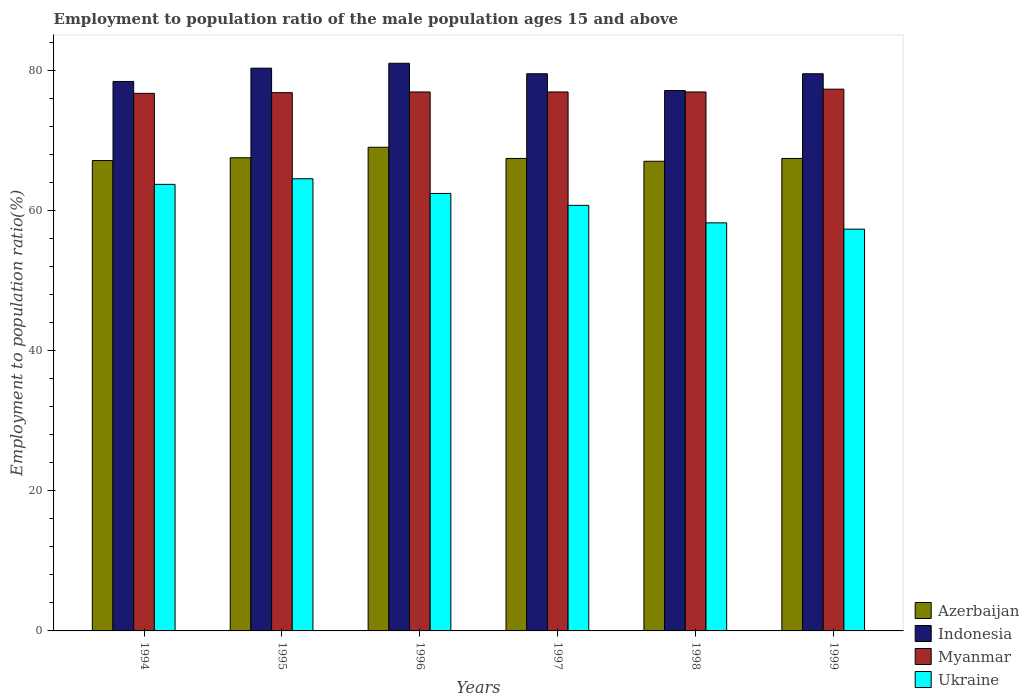How many different coloured bars are there?
Offer a terse response. 4. Are the number of bars per tick equal to the number of legend labels?
Provide a succinct answer. Yes. Are the number of bars on each tick of the X-axis equal?
Give a very brief answer. Yes. What is the label of the 2nd group of bars from the left?
Provide a short and direct response. 1995. In how many cases, is the number of bars for a given year not equal to the number of legend labels?
Give a very brief answer. 0. What is the employment to population ratio in Myanmar in 1994?
Provide a succinct answer. 76.8. Across all years, what is the maximum employment to population ratio in Ukraine?
Your answer should be compact. 64.6. Across all years, what is the minimum employment to population ratio in Ukraine?
Make the answer very short. 57.4. In which year was the employment to population ratio in Azerbaijan maximum?
Your answer should be compact. 1996. What is the total employment to population ratio in Indonesia in the graph?
Your answer should be very brief. 476.4. What is the difference between the employment to population ratio in Indonesia in 1994 and that in 1995?
Your answer should be very brief. -1.9. What is the average employment to population ratio in Azerbaijan per year?
Provide a short and direct response. 67.67. In the year 1994, what is the difference between the employment to population ratio in Myanmar and employment to population ratio in Ukraine?
Make the answer very short. 13. In how many years, is the employment to population ratio in Indonesia greater than 56 %?
Keep it short and to the point. 6. What is the ratio of the employment to population ratio in Myanmar in 1998 to that in 1999?
Give a very brief answer. 0.99. What is the difference between the highest and the second highest employment to population ratio in Ukraine?
Your answer should be compact. 0.8. What is the difference between the highest and the lowest employment to population ratio in Azerbaijan?
Provide a succinct answer. 2. Is the sum of the employment to population ratio in Indonesia in 1994 and 1999 greater than the maximum employment to population ratio in Ukraine across all years?
Your response must be concise. Yes. Is it the case that in every year, the sum of the employment to population ratio in Indonesia and employment to population ratio in Ukraine is greater than the sum of employment to population ratio in Azerbaijan and employment to population ratio in Myanmar?
Provide a succinct answer. Yes. What does the 3rd bar from the left in 1996 represents?
Offer a very short reply. Myanmar. What does the 1st bar from the right in 1996 represents?
Your answer should be compact. Ukraine. How many bars are there?
Ensure brevity in your answer.  24. Are all the bars in the graph horizontal?
Your answer should be compact. No. How many years are there in the graph?
Offer a terse response. 6. Does the graph contain grids?
Provide a succinct answer. No. Where does the legend appear in the graph?
Offer a very short reply. Bottom right. How many legend labels are there?
Provide a short and direct response. 4. What is the title of the graph?
Offer a terse response. Employment to population ratio of the male population ages 15 and above. Does "Belgium" appear as one of the legend labels in the graph?
Your response must be concise. No. What is the label or title of the Y-axis?
Your response must be concise. Employment to population ratio(%). What is the Employment to population ratio(%) in Azerbaijan in 1994?
Provide a succinct answer. 67.2. What is the Employment to population ratio(%) of Indonesia in 1994?
Give a very brief answer. 78.5. What is the Employment to population ratio(%) of Myanmar in 1994?
Give a very brief answer. 76.8. What is the Employment to population ratio(%) of Ukraine in 1994?
Make the answer very short. 63.8. What is the Employment to population ratio(%) of Azerbaijan in 1995?
Provide a succinct answer. 67.6. What is the Employment to population ratio(%) of Indonesia in 1995?
Provide a succinct answer. 80.4. What is the Employment to population ratio(%) in Myanmar in 1995?
Your response must be concise. 76.9. What is the Employment to population ratio(%) of Ukraine in 1995?
Your answer should be very brief. 64.6. What is the Employment to population ratio(%) of Azerbaijan in 1996?
Ensure brevity in your answer.  69.1. What is the Employment to population ratio(%) of Indonesia in 1996?
Make the answer very short. 81.1. What is the Employment to population ratio(%) of Ukraine in 1996?
Offer a terse response. 62.5. What is the Employment to population ratio(%) of Azerbaijan in 1997?
Provide a succinct answer. 67.5. What is the Employment to population ratio(%) of Indonesia in 1997?
Provide a succinct answer. 79.6. What is the Employment to population ratio(%) in Ukraine in 1997?
Provide a short and direct response. 60.8. What is the Employment to population ratio(%) of Azerbaijan in 1998?
Provide a short and direct response. 67.1. What is the Employment to population ratio(%) of Indonesia in 1998?
Provide a short and direct response. 77.2. What is the Employment to population ratio(%) in Myanmar in 1998?
Offer a terse response. 77. What is the Employment to population ratio(%) in Ukraine in 1998?
Keep it short and to the point. 58.3. What is the Employment to population ratio(%) in Azerbaijan in 1999?
Provide a short and direct response. 67.5. What is the Employment to population ratio(%) in Indonesia in 1999?
Provide a short and direct response. 79.6. What is the Employment to population ratio(%) of Myanmar in 1999?
Make the answer very short. 77.4. What is the Employment to population ratio(%) in Ukraine in 1999?
Give a very brief answer. 57.4. Across all years, what is the maximum Employment to population ratio(%) in Azerbaijan?
Ensure brevity in your answer.  69.1. Across all years, what is the maximum Employment to population ratio(%) in Indonesia?
Keep it short and to the point. 81.1. Across all years, what is the maximum Employment to population ratio(%) of Myanmar?
Your response must be concise. 77.4. Across all years, what is the maximum Employment to population ratio(%) of Ukraine?
Ensure brevity in your answer.  64.6. Across all years, what is the minimum Employment to population ratio(%) of Azerbaijan?
Offer a terse response. 67.1. Across all years, what is the minimum Employment to population ratio(%) in Indonesia?
Make the answer very short. 77.2. Across all years, what is the minimum Employment to population ratio(%) in Myanmar?
Give a very brief answer. 76.8. Across all years, what is the minimum Employment to population ratio(%) of Ukraine?
Provide a short and direct response. 57.4. What is the total Employment to population ratio(%) in Azerbaijan in the graph?
Offer a very short reply. 406. What is the total Employment to population ratio(%) in Indonesia in the graph?
Your answer should be very brief. 476.4. What is the total Employment to population ratio(%) of Myanmar in the graph?
Provide a short and direct response. 462.1. What is the total Employment to population ratio(%) in Ukraine in the graph?
Your answer should be very brief. 367.4. What is the difference between the Employment to population ratio(%) in Indonesia in 1994 and that in 1995?
Give a very brief answer. -1.9. What is the difference between the Employment to population ratio(%) of Myanmar in 1994 and that in 1995?
Offer a terse response. -0.1. What is the difference between the Employment to population ratio(%) in Ukraine in 1994 and that in 1995?
Keep it short and to the point. -0.8. What is the difference between the Employment to population ratio(%) in Azerbaijan in 1994 and that in 1996?
Your answer should be compact. -1.9. What is the difference between the Employment to population ratio(%) of Indonesia in 1994 and that in 1996?
Provide a short and direct response. -2.6. What is the difference between the Employment to population ratio(%) of Ukraine in 1994 and that in 1996?
Provide a short and direct response. 1.3. What is the difference between the Employment to population ratio(%) of Azerbaijan in 1994 and that in 1997?
Provide a short and direct response. -0.3. What is the difference between the Employment to population ratio(%) in Indonesia in 1994 and that in 1997?
Your response must be concise. -1.1. What is the difference between the Employment to population ratio(%) of Azerbaijan in 1994 and that in 1998?
Provide a succinct answer. 0.1. What is the difference between the Employment to population ratio(%) of Ukraine in 1994 and that in 1998?
Your response must be concise. 5.5. What is the difference between the Employment to population ratio(%) of Myanmar in 1994 and that in 1999?
Your answer should be compact. -0.6. What is the difference between the Employment to population ratio(%) in Indonesia in 1995 and that in 1996?
Your response must be concise. -0.7. What is the difference between the Employment to population ratio(%) in Myanmar in 1995 and that in 1996?
Offer a very short reply. -0.1. What is the difference between the Employment to population ratio(%) in Ukraine in 1995 and that in 1996?
Provide a short and direct response. 2.1. What is the difference between the Employment to population ratio(%) of Azerbaijan in 1995 and that in 1997?
Offer a terse response. 0.1. What is the difference between the Employment to population ratio(%) of Indonesia in 1995 and that in 1998?
Make the answer very short. 3.2. What is the difference between the Employment to population ratio(%) in Myanmar in 1995 and that in 1998?
Your answer should be very brief. -0.1. What is the difference between the Employment to population ratio(%) in Indonesia in 1995 and that in 1999?
Provide a succinct answer. 0.8. What is the difference between the Employment to population ratio(%) in Myanmar in 1995 and that in 1999?
Your answer should be very brief. -0.5. What is the difference between the Employment to population ratio(%) in Indonesia in 1996 and that in 1998?
Your response must be concise. 3.9. What is the difference between the Employment to population ratio(%) in Myanmar in 1996 and that in 1998?
Offer a terse response. 0. What is the difference between the Employment to population ratio(%) of Azerbaijan in 1996 and that in 1999?
Provide a succinct answer. 1.6. What is the difference between the Employment to population ratio(%) in Indonesia in 1996 and that in 1999?
Provide a succinct answer. 1.5. What is the difference between the Employment to population ratio(%) of Myanmar in 1996 and that in 1999?
Make the answer very short. -0.4. What is the difference between the Employment to population ratio(%) in Ukraine in 1996 and that in 1999?
Give a very brief answer. 5.1. What is the difference between the Employment to population ratio(%) in Azerbaijan in 1997 and that in 1998?
Your answer should be very brief. 0.4. What is the difference between the Employment to population ratio(%) of Myanmar in 1997 and that in 1998?
Offer a terse response. 0. What is the difference between the Employment to population ratio(%) of Azerbaijan in 1997 and that in 1999?
Offer a terse response. 0. What is the difference between the Employment to population ratio(%) of Myanmar in 1997 and that in 1999?
Your response must be concise. -0.4. What is the difference between the Employment to population ratio(%) of Azerbaijan in 1994 and the Employment to population ratio(%) of Indonesia in 1995?
Offer a terse response. -13.2. What is the difference between the Employment to population ratio(%) of Azerbaijan in 1994 and the Employment to population ratio(%) of Myanmar in 1995?
Your response must be concise. -9.7. What is the difference between the Employment to population ratio(%) in Azerbaijan in 1994 and the Employment to population ratio(%) in Ukraine in 1995?
Your response must be concise. 2.6. What is the difference between the Employment to population ratio(%) of Indonesia in 1994 and the Employment to population ratio(%) of Ukraine in 1995?
Ensure brevity in your answer.  13.9. What is the difference between the Employment to population ratio(%) in Myanmar in 1994 and the Employment to population ratio(%) in Ukraine in 1995?
Offer a terse response. 12.2. What is the difference between the Employment to population ratio(%) of Indonesia in 1994 and the Employment to population ratio(%) of Myanmar in 1996?
Provide a succinct answer. 1.5. What is the difference between the Employment to population ratio(%) of Indonesia in 1994 and the Employment to population ratio(%) of Ukraine in 1996?
Provide a short and direct response. 16. What is the difference between the Employment to population ratio(%) of Azerbaijan in 1994 and the Employment to population ratio(%) of Indonesia in 1997?
Your answer should be very brief. -12.4. What is the difference between the Employment to population ratio(%) in Myanmar in 1994 and the Employment to population ratio(%) in Ukraine in 1997?
Keep it short and to the point. 16. What is the difference between the Employment to population ratio(%) of Azerbaijan in 1994 and the Employment to population ratio(%) of Indonesia in 1998?
Offer a very short reply. -10. What is the difference between the Employment to population ratio(%) of Indonesia in 1994 and the Employment to population ratio(%) of Myanmar in 1998?
Keep it short and to the point. 1.5. What is the difference between the Employment to population ratio(%) of Indonesia in 1994 and the Employment to population ratio(%) of Ukraine in 1998?
Your response must be concise. 20.2. What is the difference between the Employment to population ratio(%) in Azerbaijan in 1994 and the Employment to population ratio(%) in Ukraine in 1999?
Make the answer very short. 9.8. What is the difference between the Employment to population ratio(%) of Indonesia in 1994 and the Employment to population ratio(%) of Myanmar in 1999?
Provide a short and direct response. 1.1. What is the difference between the Employment to population ratio(%) in Indonesia in 1994 and the Employment to population ratio(%) in Ukraine in 1999?
Provide a short and direct response. 21.1. What is the difference between the Employment to population ratio(%) in Myanmar in 1994 and the Employment to population ratio(%) in Ukraine in 1999?
Your response must be concise. 19.4. What is the difference between the Employment to population ratio(%) in Azerbaijan in 1995 and the Employment to population ratio(%) in Indonesia in 1996?
Your answer should be very brief. -13.5. What is the difference between the Employment to population ratio(%) in Azerbaijan in 1995 and the Employment to population ratio(%) in Myanmar in 1996?
Provide a short and direct response. -9.4. What is the difference between the Employment to population ratio(%) of Indonesia in 1995 and the Employment to population ratio(%) of Myanmar in 1996?
Provide a succinct answer. 3.4. What is the difference between the Employment to population ratio(%) of Indonesia in 1995 and the Employment to population ratio(%) of Ukraine in 1996?
Offer a terse response. 17.9. What is the difference between the Employment to population ratio(%) of Azerbaijan in 1995 and the Employment to population ratio(%) of Indonesia in 1997?
Make the answer very short. -12. What is the difference between the Employment to population ratio(%) in Azerbaijan in 1995 and the Employment to population ratio(%) in Myanmar in 1997?
Give a very brief answer. -9.4. What is the difference between the Employment to population ratio(%) of Azerbaijan in 1995 and the Employment to population ratio(%) of Ukraine in 1997?
Provide a succinct answer. 6.8. What is the difference between the Employment to population ratio(%) in Indonesia in 1995 and the Employment to population ratio(%) in Myanmar in 1997?
Provide a short and direct response. 3.4. What is the difference between the Employment to population ratio(%) of Indonesia in 1995 and the Employment to population ratio(%) of Ukraine in 1997?
Your response must be concise. 19.6. What is the difference between the Employment to population ratio(%) in Azerbaijan in 1995 and the Employment to population ratio(%) in Indonesia in 1998?
Provide a short and direct response. -9.6. What is the difference between the Employment to population ratio(%) in Azerbaijan in 1995 and the Employment to population ratio(%) in Myanmar in 1998?
Offer a very short reply. -9.4. What is the difference between the Employment to population ratio(%) of Azerbaijan in 1995 and the Employment to population ratio(%) of Ukraine in 1998?
Your answer should be very brief. 9.3. What is the difference between the Employment to population ratio(%) in Indonesia in 1995 and the Employment to population ratio(%) in Myanmar in 1998?
Give a very brief answer. 3.4. What is the difference between the Employment to population ratio(%) in Indonesia in 1995 and the Employment to population ratio(%) in Ukraine in 1998?
Your answer should be very brief. 22.1. What is the difference between the Employment to population ratio(%) of Myanmar in 1995 and the Employment to population ratio(%) of Ukraine in 1998?
Provide a succinct answer. 18.6. What is the difference between the Employment to population ratio(%) of Indonesia in 1995 and the Employment to population ratio(%) of Myanmar in 1999?
Give a very brief answer. 3. What is the difference between the Employment to population ratio(%) of Myanmar in 1995 and the Employment to population ratio(%) of Ukraine in 1999?
Provide a succinct answer. 19.5. What is the difference between the Employment to population ratio(%) in Azerbaijan in 1996 and the Employment to population ratio(%) in Indonesia in 1997?
Keep it short and to the point. -10.5. What is the difference between the Employment to population ratio(%) in Azerbaijan in 1996 and the Employment to population ratio(%) in Ukraine in 1997?
Give a very brief answer. 8.3. What is the difference between the Employment to population ratio(%) in Indonesia in 1996 and the Employment to population ratio(%) in Myanmar in 1997?
Your answer should be very brief. 4.1. What is the difference between the Employment to population ratio(%) in Indonesia in 1996 and the Employment to population ratio(%) in Ukraine in 1997?
Your answer should be compact. 20.3. What is the difference between the Employment to population ratio(%) in Myanmar in 1996 and the Employment to population ratio(%) in Ukraine in 1997?
Provide a succinct answer. 16.2. What is the difference between the Employment to population ratio(%) of Azerbaijan in 1996 and the Employment to population ratio(%) of Indonesia in 1998?
Offer a very short reply. -8.1. What is the difference between the Employment to population ratio(%) of Azerbaijan in 1996 and the Employment to population ratio(%) of Ukraine in 1998?
Provide a short and direct response. 10.8. What is the difference between the Employment to population ratio(%) in Indonesia in 1996 and the Employment to population ratio(%) in Myanmar in 1998?
Your answer should be compact. 4.1. What is the difference between the Employment to population ratio(%) in Indonesia in 1996 and the Employment to population ratio(%) in Ukraine in 1998?
Offer a very short reply. 22.8. What is the difference between the Employment to population ratio(%) of Myanmar in 1996 and the Employment to population ratio(%) of Ukraine in 1998?
Offer a terse response. 18.7. What is the difference between the Employment to population ratio(%) of Azerbaijan in 1996 and the Employment to population ratio(%) of Myanmar in 1999?
Provide a succinct answer. -8.3. What is the difference between the Employment to population ratio(%) of Indonesia in 1996 and the Employment to population ratio(%) of Ukraine in 1999?
Give a very brief answer. 23.7. What is the difference between the Employment to population ratio(%) in Myanmar in 1996 and the Employment to population ratio(%) in Ukraine in 1999?
Your answer should be very brief. 19.6. What is the difference between the Employment to population ratio(%) in Azerbaijan in 1997 and the Employment to population ratio(%) in Myanmar in 1998?
Ensure brevity in your answer.  -9.5. What is the difference between the Employment to population ratio(%) of Azerbaijan in 1997 and the Employment to population ratio(%) of Ukraine in 1998?
Offer a terse response. 9.2. What is the difference between the Employment to population ratio(%) in Indonesia in 1997 and the Employment to population ratio(%) in Myanmar in 1998?
Ensure brevity in your answer.  2.6. What is the difference between the Employment to population ratio(%) of Indonesia in 1997 and the Employment to population ratio(%) of Ukraine in 1998?
Your answer should be very brief. 21.3. What is the difference between the Employment to population ratio(%) of Myanmar in 1997 and the Employment to population ratio(%) of Ukraine in 1998?
Your answer should be very brief. 18.7. What is the difference between the Employment to population ratio(%) in Azerbaijan in 1997 and the Employment to population ratio(%) in Indonesia in 1999?
Ensure brevity in your answer.  -12.1. What is the difference between the Employment to population ratio(%) of Indonesia in 1997 and the Employment to population ratio(%) of Ukraine in 1999?
Keep it short and to the point. 22.2. What is the difference between the Employment to population ratio(%) in Myanmar in 1997 and the Employment to population ratio(%) in Ukraine in 1999?
Make the answer very short. 19.6. What is the difference between the Employment to population ratio(%) of Azerbaijan in 1998 and the Employment to population ratio(%) of Indonesia in 1999?
Your response must be concise. -12.5. What is the difference between the Employment to population ratio(%) in Azerbaijan in 1998 and the Employment to population ratio(%) in Ukraine in 1999?
Your answer should be compact. 9.7. What is the difference between the Employment to population ratio(%) in Indonesia in 1998 and the Employment to population ratio(%) in Myanmar in 1999?
Give a very brief answer. -0.2. What is the difference between the Employment to population ratio(%) of Indonesia in 1998 and the Employment to population ratio(%) of Ukraine in 1999?
Your answer should be very brief. 19.8. What is the difference between the Employment to population ratio(%) of Myanmar in 1998 and the Employment to population ratio(%) of Ukraine in 1999?
Keep it short and to the point. 19.6. What is the average Employment to population ratio(%) in Azerbaijan per year?
Ensure brevity in your answer.  67.67. What is the average Employment to population ratio(%) in Indonesia per year?
Provide a short and direct response. 79.4. What is the average Employment to population ratio(%) of Myanmar per year?
Keep it short and to the point. 77.02. What is the average Employment to population ratio(%) in Ukraine per year?
Your answer should be very brief. 61.23. In the year 1994, what is the difference between the Employment to population ratio(%) of Azerbaijan and Employment to population ratio(%) of Indonesia?
Offer a very short reply. -11.3. In the year 1994, what is the difference between the Employment to population ratio(%) in Azerbaijan and Employment to population ratio(%) in Myanmar?
Your answer should be very brief. -9.6. In the year 1994, what is the difference between the Employment to population ratio(%) of Azerbaijan and Employment to population ratio(%) of Ukraine?
Your response must be concise. 3.4. In the year 1994, what is the difference between the Employment to population ratio(%) of Indonesia and Employment to population ratio(%) of Myanmar?
Your answer should be compact. 1.7. In the year 1994, what is the difference between the Employment to population ratio(%) in Indonesia and Employment to population ratio(%) in Ukraine?
Your response must be concise. 14.7. In the year 1994, what is the difference between the Employment to population ratio(%) in Myanmar and Employment to population ratio(%) in Ukraine?
Give a very brief answer. 13. In the year 1995, what is the difference between the Employment to population ratio(%) of Indonesia and Employment to population ratio(%) of Myanmar?
Your response must be concise. 3.5. In the year 1995, what is the difference between the Employment to population ratio(%) in Indonesia and Employment to population ratio(%) in Ukraine?
Provide a succinct answer. 15.8. In the year 1995, what is the difference between the Employment to population ratio(%) in Myanmar and Employment to population ratio(%) in Ukraine?
Make the answer very short. 12.3. In the year 1996, what is the difference between the Employment to population ratio(%) in Azerbaijan and Employment to population ratio(%) in Ukraine?
Give a very brief answer. 6.6. In the year 1996, what is the difference between the Employment to population ratio(%) in Indonesia and Employment to population ratio(%) in Ukraine?
Your answer should be compact. 18.6. In the year 1996, what is the difference between the Employment to population ratio(%) of Myanmar and Employment to population ratio(%) of Ukraine?
Make the answer very short. 14.5. In the year 1997, what is the difference between the Employment to population ratio(%) in Azerbaijan and Employment to population ratio(%) in Indonesia?
Ensure brevity in your answer.  -12.1. In the year 1997, what is the difference between the Employment to population ratio(%) in Azerbaijan and Employment to population ratio(%) in Ukraine?
Make the answer very short. 6.7. In the year 1997, what is the difference between the Employment to population ratio(%) of Indonesia and Employment to population ratio(%) of Myanmar?
Provide a succinct answer. 2.6. In the year 1997, what is the difference between the Employment to population ratio(%) of Indonesia and Employment to population ratio(%) of Ukraine?
Your response must be concise. 18.8. In the year 1997, what is the difference between the Employment to population ratio(%) of Myanmar and Employment to population ratio(%) of Ukraine?
Ensure brevity in your answer.  16.2. In the year 1998, what is the difference between the Employment to population ratio(%) of Azerbaijan and Employment to population ratio(%) of Ukraine?
Make the answer very short. 8.8. In the year 1998, what is the difference between the Employment to population ratio(%) in Indonesia and Employment to population ratio(%) in Ukraine?
Your answer should be compact. 18.9. In the year 1998, what is the difference between the Employment to population ratio(%) in Myanmar and Employment to population ratio(%) in Ukraine?
Your response must be concise. 18.7. In the year 1999, what is the difference between the Employment to population ratio(%) in Myanmar and Employment to population ratio(%) in Ukraine?
Offer a very short reply. 20. What is the ratio of the Employment to population ratio(%) in Indonesia in 1994 to that in 1995?
Keep it short and to the point. 0.98. What is the ratio of the Employment to population ratio(%) of Myanmar in 1994 to that in 1995?
Provide a succinct answer. 1. What is the ratio of the Employment to population ratio(%) in Ukraine in 1994 to that in 1995?
Ensure brevity in your answer.  0.99. What is the ratio of the Employment to population ratio(%) of Azerbaijan in 1994 to that in 1996?
Make the answer very short. 0.97. What is the ratio of the Employment to population ratio(%) in Indonesia in 1994 to that in 1996?
Your answer should be very brief. 0.97. What is the ratio of the Employment to population ratio(%) in Ukraine in 1994 to that in 1996?
Keep it short and to the point. 1.02. What is the ratio of the Employment to population ratio(%) in Azerbaijan in 1994 to that in 1997?
Your response must be concise. 1. What is the ratio of the Employment to population ratio(%) in Indonesia in 1994 to that in 1997?
Provide a succinct answer. 0.99. What is the ratio of the Employment to population ratio(%) in Ukraine in 1994 to that in 1997?
Offer a very short reply. 1.05. What is the ratio of the Employment to population ratio(%) of Azerbaijan in 1994 to that in 1998?
Your response must be concise. 1. What is the ratio of the Employment to population ratio(%) of Indonesia in 1994 to that in 1998?
Your answer should be very brief. 1.02. What is the ratio of the Employment to population ratio(%) in Myanmar in 1994 to that in 1998?
Make the answer very short. 1. What is the ratio of the Employment to population ratio(%) of Ukraine in 1994 to that in 1998?
Ensure brevity in your answer.  1.09. What is the ratio of the Employment to population ratio(%) of Azerbaijan in 1994 to that in 1999?
Provide a short and direct response. 1. What is the ratio of the Employment to population ratio(%) of Indonesia in 1994 to that in 1999?
Your answer should be very brief. 0.99. What is the ratio of the Employment to population ratio(%) of Ukraine in 1994 to that in 1999?
Ensure brevity in your answer.  1.11. What is the ratio of the Employment to population ratio(%) of Azerbaijan in 1995 to that in 1996?
Your answer should be compact. 0.98. What is the ratio of the Employment to population ratio(%) of Indonesia in 1995 to that in 1996?
Give a very brief answer. 0.99. What is the ratio of the Employment to population ratio(%) of Ukraine in 1995 to that in 1996?
Your response must be concise. 1.03. What is the ratio of the Employment to population ratio(%) in Azerbaijan in 1995 to that in 1997?
Your answer should be compact. 1. What is the ratio of the Employment to population ratio(%) in Indonesia in 1995 to that in 1997?
Keep it short and to the point. 1.01. What is the ratio of the Employment to population ratio(%) of Myanmar in 1995 to that in 1997?
Provide a short and direct response. 1. What is the ratio of the Employment to population ratio(%) in Ukraine in 1995 to that in 1997?
Make the answer very short. 1.06. What is the ratio of the Employment to population ratio(%) in Azerbaijan in 1995 to that in 1998?
Your response must be concise. 1.01. What is the ratio of the Employment to population ratio(%) in Indonesia in 1995 to that in 1998?
Provide a succinct answer. 1.04. What is the ratio of the Employment to population ratio(%) in Ukraine in 1995 to that in 1998?
Keep it short and to the point. 1.11. What is the ratio of the Employment to population ratio(%) of Indonesia in 1995 to that in 1999?
Your response must be concise. 1.01. What is the ratio of the Employment to population ratio(%) of Myanmar in 1995 to that in 1999?
Your response must be concise. 0.99. What is the ratio of the Employment to population ratio(%) in Ukraine in 1995 to that in 1999?
Offer a very short reply. 1.13. What is the ratio of the Employment to population ratio(%) in Azerbaijan in 1996 to that in 1997?
Give a very brief answer. 1.02. What is the ratio of the Employment to population ratio(%) in Indonesia in 1996 to that in 1997?
Offer a terse response. 1.02. What is the ratio of the Employment to population ratio(%) of Ukraine in 1996 to that in 1997?
Offer a terse response. 1.03. What is the ratio of the Employment to population ratio(%) of Azerbaijan in 1996 to that in 1998?
Your response must be concise. 1.03. What is the ratio of the Employment to population ratio(%) in Indonesia in 1996 to that in 1998?
Your response must be concise. 1.05. What is the ratio of the Employment to population ratio(%) of Ukraine in 1996 to that in 1998?
Provide a short and direct response. 1.07. What is the ratio of the Employment to population ratio(%) of Azerbaijan in 1996 to that in 1999?
Provide a short and direct response. 1.02. What is the ratio of the Employment to population ratio(%) of Indonesia in 1996 to that in 1999?
Provide a short and direct response. 1.02. What is the ratio of the Employment to population ratio(%) in Ukraine in 1996 to that in 1999?
Make the answer very short. 1.09. What is the ratio of the Employment to population ratio(%) of Azerbaijan in 1997 to that in 1998?
Give a very brief answer. 1.01. What is the ratio of the Employment to population ratio(%) in Indonesia in 1997 to that in 1998?
Offer a terse response. 1.03. What is the ratio of the Employment to population ratio(%) of Myanmar in 1997 to that in 1998?
Ensure brevity in your answer.  1. What is the ratio of the Employment to population ratio(%) in Ukraine in 1997 to that in 1998?
Keep it short and to the point. 1.04. What is the ratio of the Employment to population ratio(%) of Indonesia in 1997 to that in 1999?
Your response must be concise. 1. What is the ratio of the Employment to population ratio(%) of Ukraine in 1997 to that in 1999?
Keep it short and to the point. 1.06. What is the ratio of the Employment to population ratio(%) in Indonesia in 1998 to that in 1999?
Ensure brevity in your answer.  0.97. What is the ratio of the Employment to population ratio(%) of Ukraine in 1998 to that in 1999?
Offer a terse response. 1.02. What is the difference between the highest and the lowest Employment to population ratio(%) of Indonesia?
Make the answer very short. 3.9. What is the difference between the highest and the lowest Employment to population ratio(%) of Ukraine?
Your response must be concise. 7.2. 